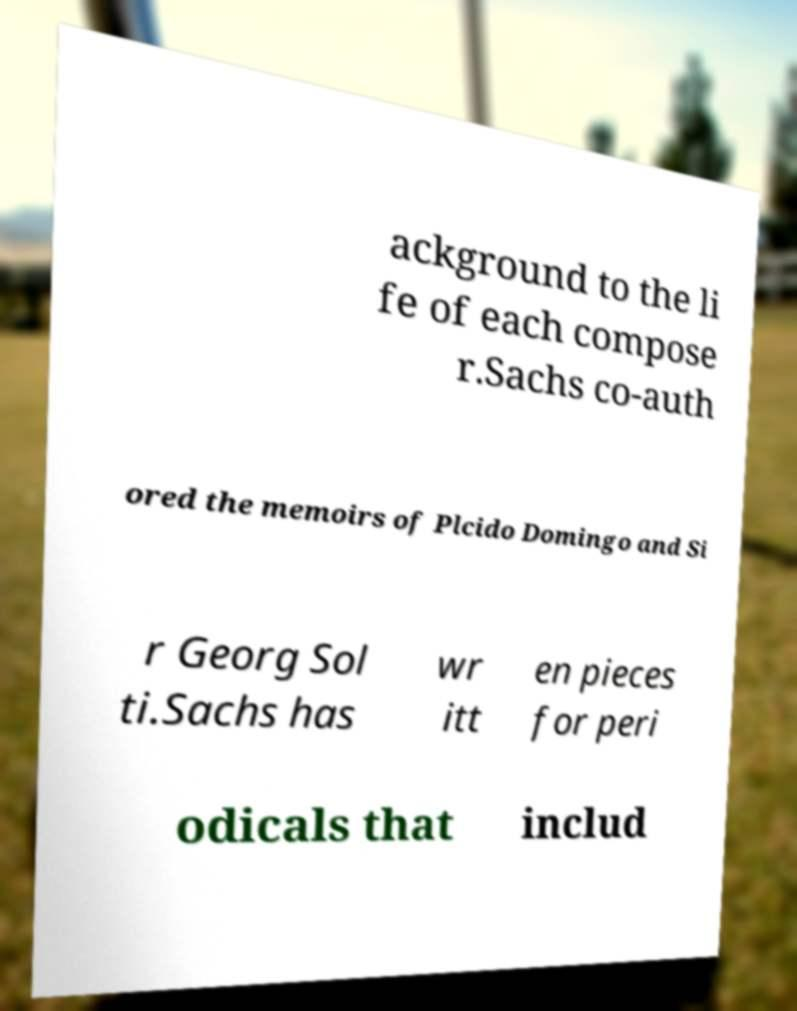I need the written content from this picture converted into text. Can you do that? ackground to the li fe of each compose r.Sachs co-auth ored the memoirs of Plcido Domingo and Si r Georg Sol ti.Sachs has wr itt en pieces for peri odicals that includ 